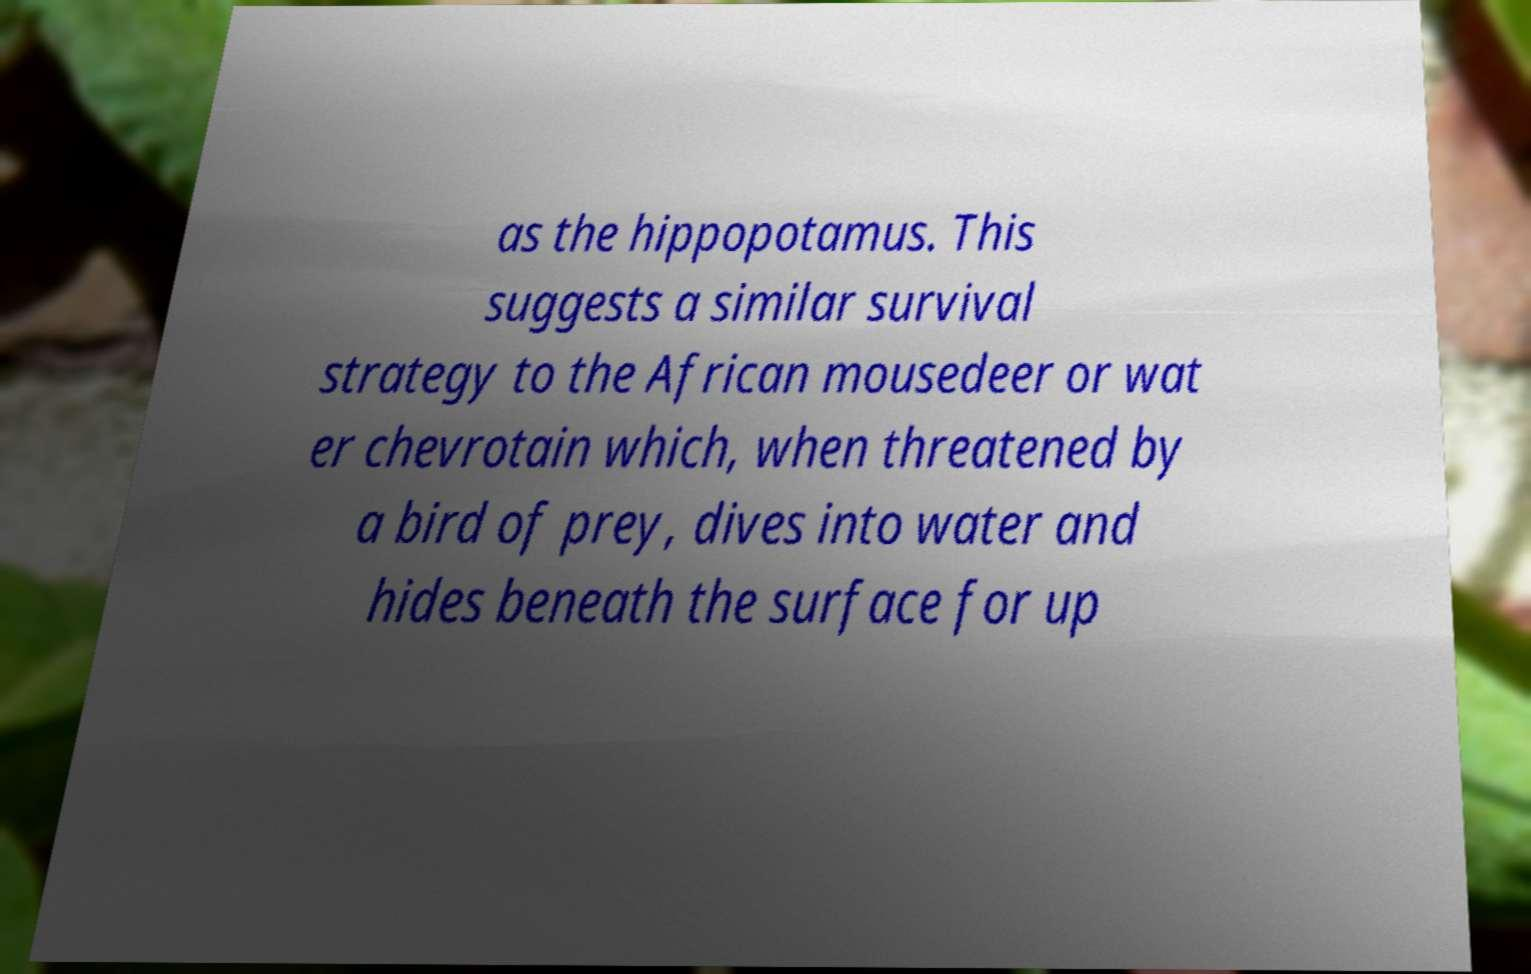Can you read and provide the text displayed in the image?This photo seems to have some interesting text. Can you extract and type it out for me? as the hippopotamus. This suggests a similar survival strategy to the African mousedeer or wat er chevrotain which, when threatened by a bird of prey, dives into water and hides beneath the surface for up 